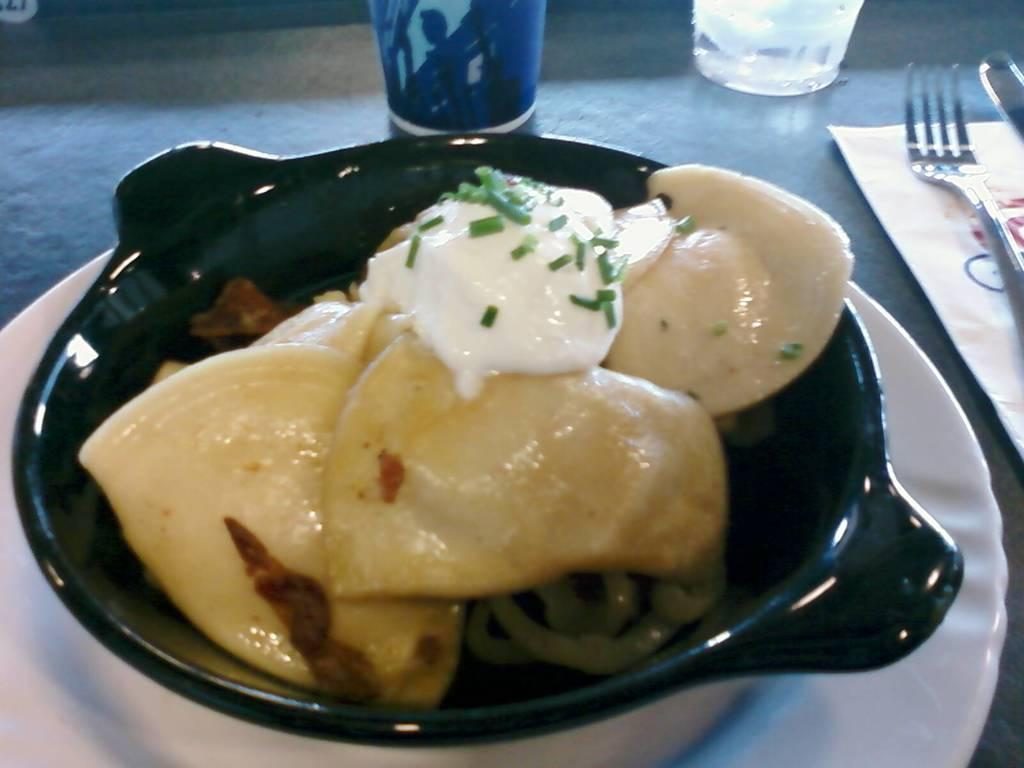What type of furniture is present in the image? There is a table in the image. What items can be seen on the table? There are glasses, a paper, a fork, a spoon, a plate, and a bowl containing food on the table. What utensils are present on the table? There is a fork and a spoon on the table. What type of dish is present on the table? There is a bowl containing food on the table. How much does the fan weigh in the image? There is no fan present in the image, so it is not possible to determine its weight. 